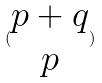<formula> <loc_0><loc_0><loc_500><loc_500>( \begin{matrix} p + q \\ p \end{matrix} )</formula> 